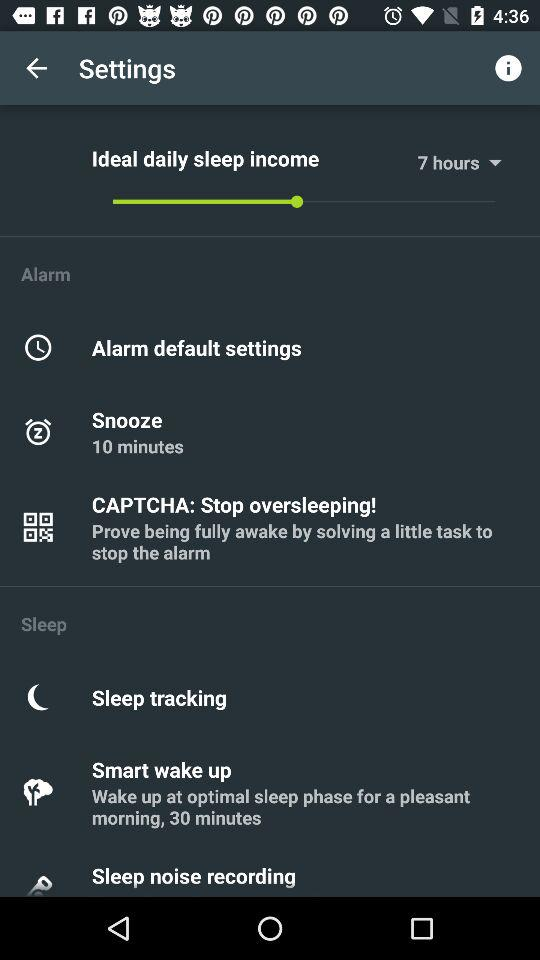What is the setting for "Ideal daily sleep income"? The setting for "Ideal daily sleep income" is 7 hours. 